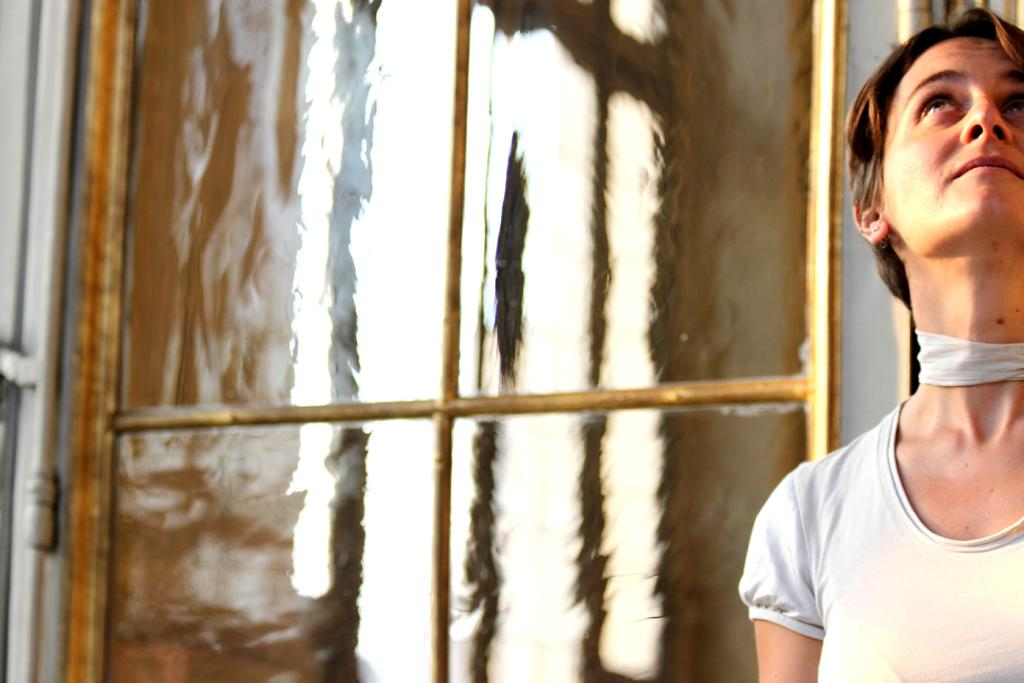What is the main subject of the image? There is a woman in the image. Can you describe the setting or background of the image? There may be a glass window behind the woman. How does the woman's grandfather compare to the base of the image? There is no mention of a grandfather or a base in the image, so it is not possible to make a comparison. 